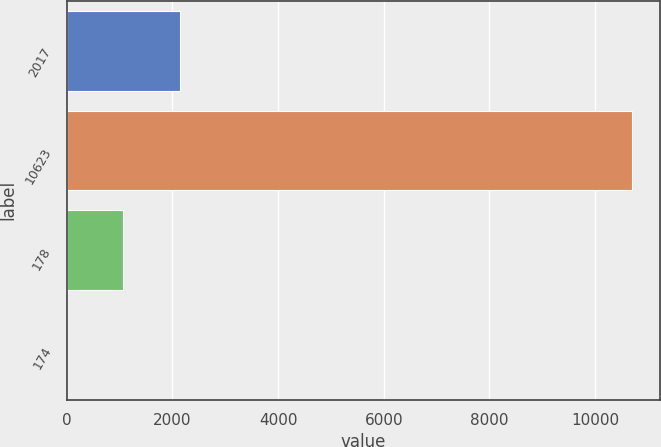<chart> <loc_0><loc_0><loc_500><loc_500><bar_chart><fcel>2017<fcel>10623<fcel>178<fcel>174<nl><fcel>2140.12<fcel>10696<fcel>1070.64<fcel>1.15<nl></chart> 